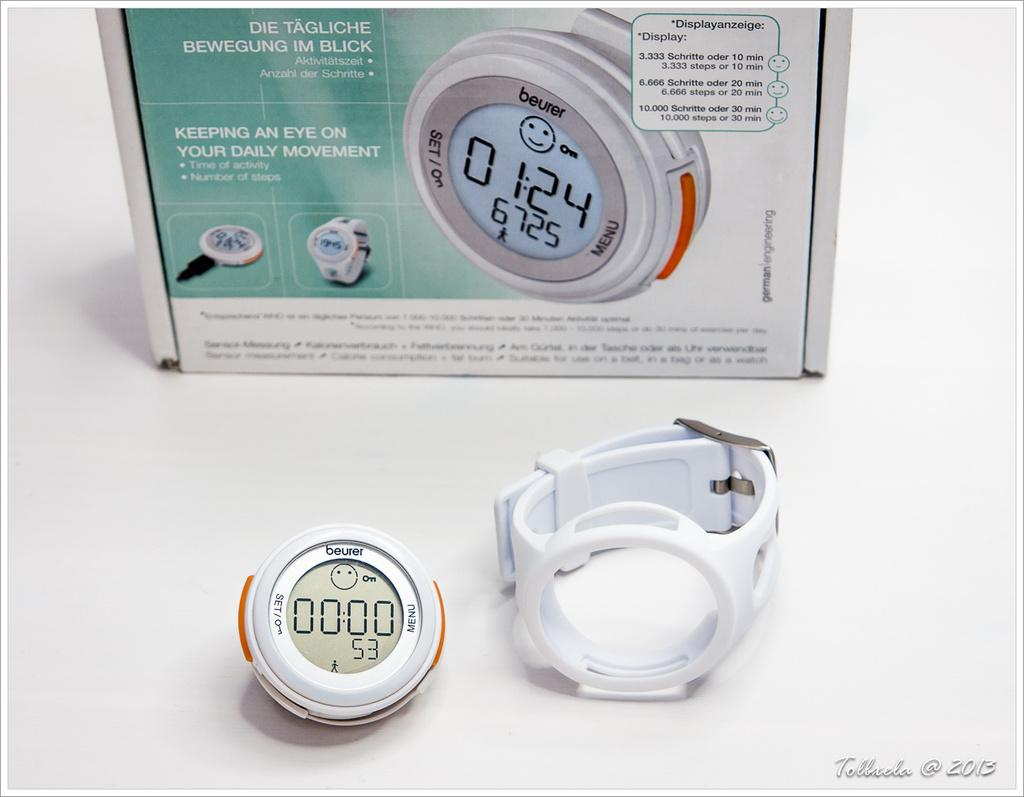<image>
Render a clear and concise summary of the photo. A beurer pedometer and the box that it came in. 